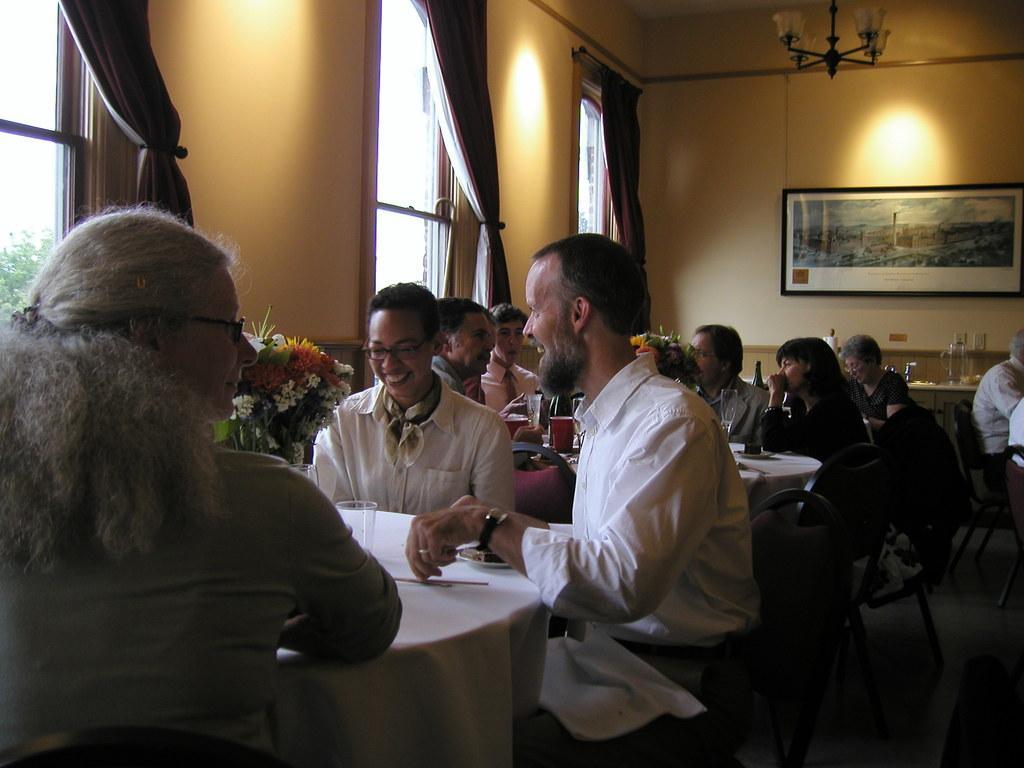Describe this image in one or two sentences. In this image I can see it looks like a restaurant, a group of people are sitting on the chairs around dining tables and talking each other. On the right side there is a photo frame on the wall, on the left side there are windows and there is a flower vase on the table. 